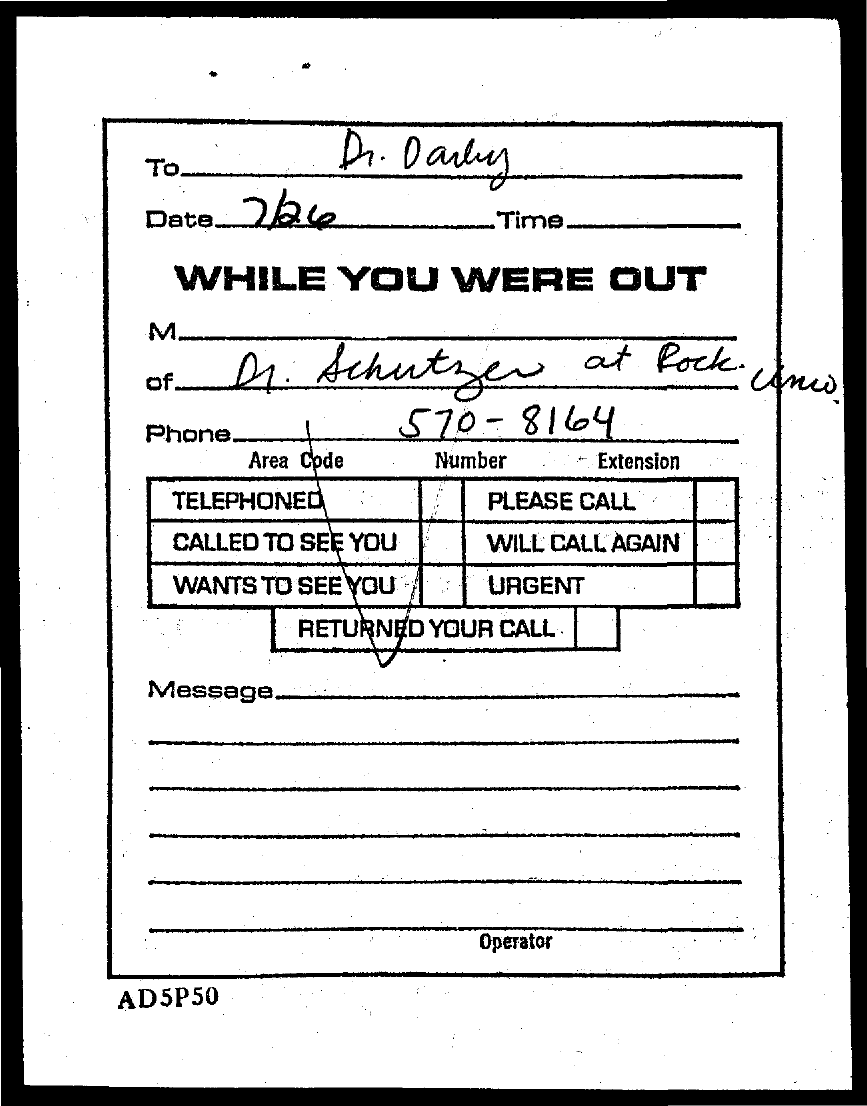What is the phone no mentioned in this document?
Offer a very short reply. 570 - 8164. To whom, the document is addressed?
Keep it short and to the point. Dr. Darby. What is the date mentioned in this document?
Offer a very short reply. 7/26. 